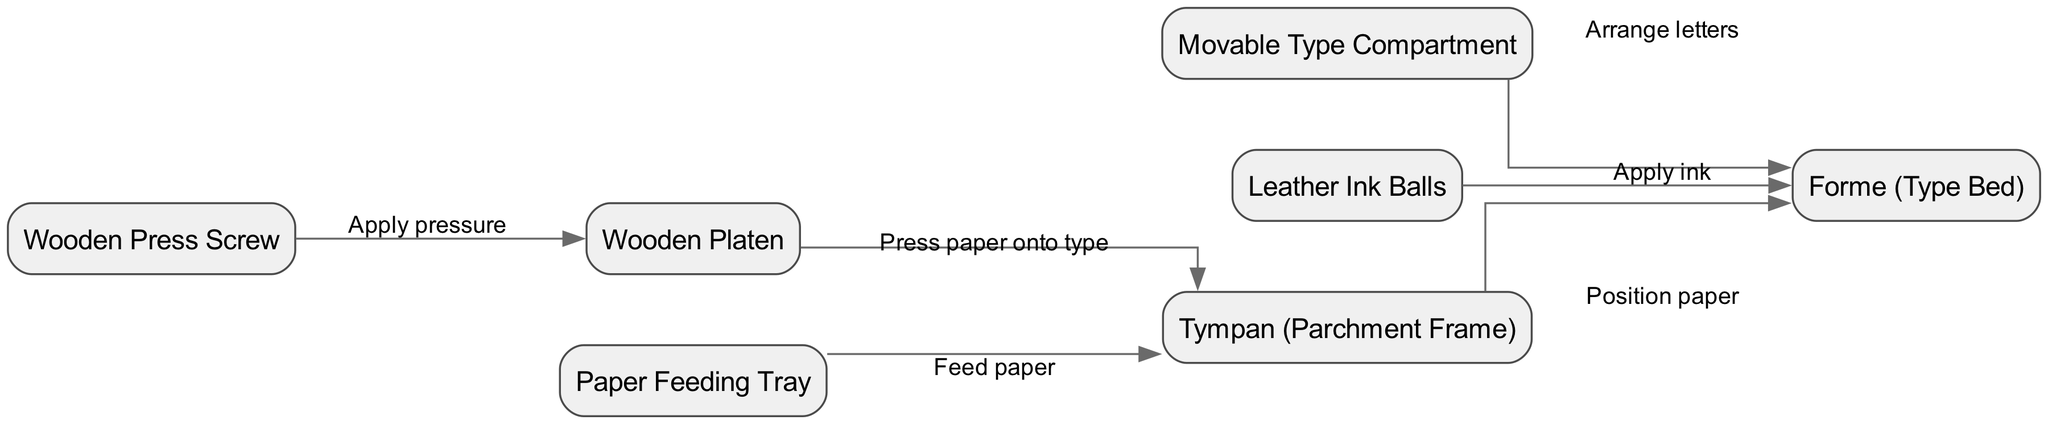What are the two primary components involved in applying ink? The diagram shows "Leather Ink Balls" as the node used for applying ink, which has a directional edge leading to the "Forme (Type Bed)." Thus, these two components involved in the ink application are "Leather Ink Balls" and "Forme (Type Bed)."
Answer: Leather Ink Balls, Forme (Type Bed) How many mechanical components are illustrated in the diagram? By counting the nodes in the diagram, there are a total of six distinct mechanical components: "Movable Type Compartment," "Leather Ink Balls," "Wooden Press Screw," "Wooden Platen," "Paper Feeding Tray," and "Tympan (Parchment Frame)." Therefore, the total number is six.
Answer: 6 What action connects the Paper Feeding Tray to the Tympan? The edge from "Paper Feeding Tray" to "Tympan (Parchment Frame)" is labeled "Feed paper," indicating the direct action that occurs between these two components.
Answer: Feed paper What is the final action performed onto the paper as indicated in the diagram? The diagram shows an edge from "Wooden Platen" to "Tympan" labeled "Press paper onto type," signifying that this is the final action involved in the printing process. This encapsulates the culmination of the mechanical steps leading to the final print on the paper.
Answer: Press paper onto type Which component arranges letters before printing? In the diagram, the "Movable Type Compartment" is directly linked to the "Forme (Type Bed)" with the action labeled "Arrange letters." This indicates that the movable type compartment is tasked with arranging the letters before the printing process.
Answer: Movable Type Compartment 